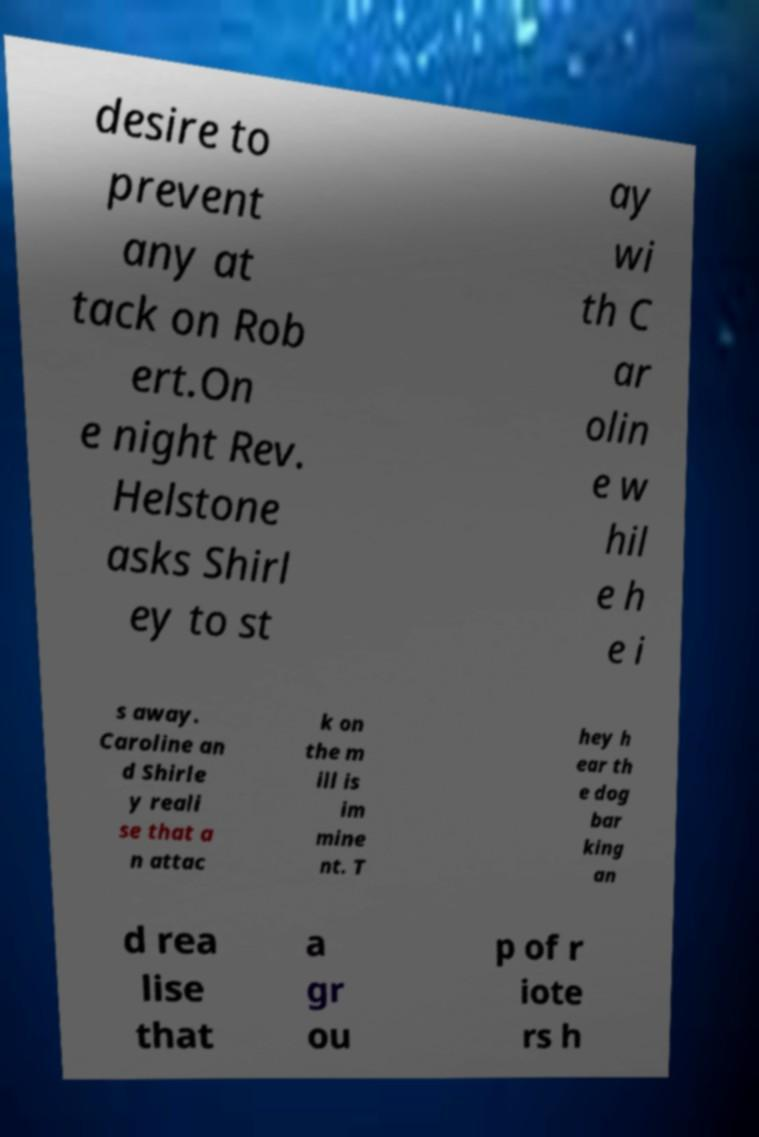Could you extract and type out the text from this image? desire to prevent any at tack on Rob ert.On e night Rev. Helstone asks Shirl ey to st ay wi th C ar olin e w hil e h e i s away. Caroline an d Shirle y reali se that a n attac k on the m ill is im mine nt. T hey h ear th e dog bar king an d rea lise that a gr ou p of r iote rs h 